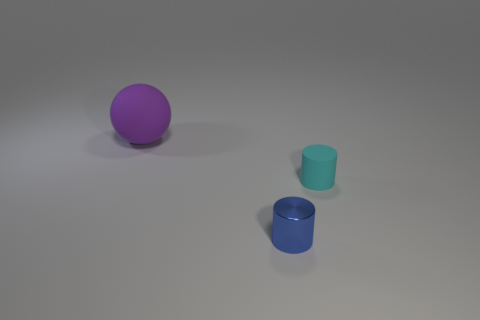What could be the possible uses for the objects in this image? The objects seem like simplified representations, possibly used for a variety of purposes. The purple sphere could be a model for educational purposes, perhaps to demonstrate geometry. The cyan and blue cylinders might be containers. The smaller one could be used to hold pens on a desk or serve as a drinking cup, while the larger one might be useful for storing larger items or even as a vase for flowers, given its size and shape. 